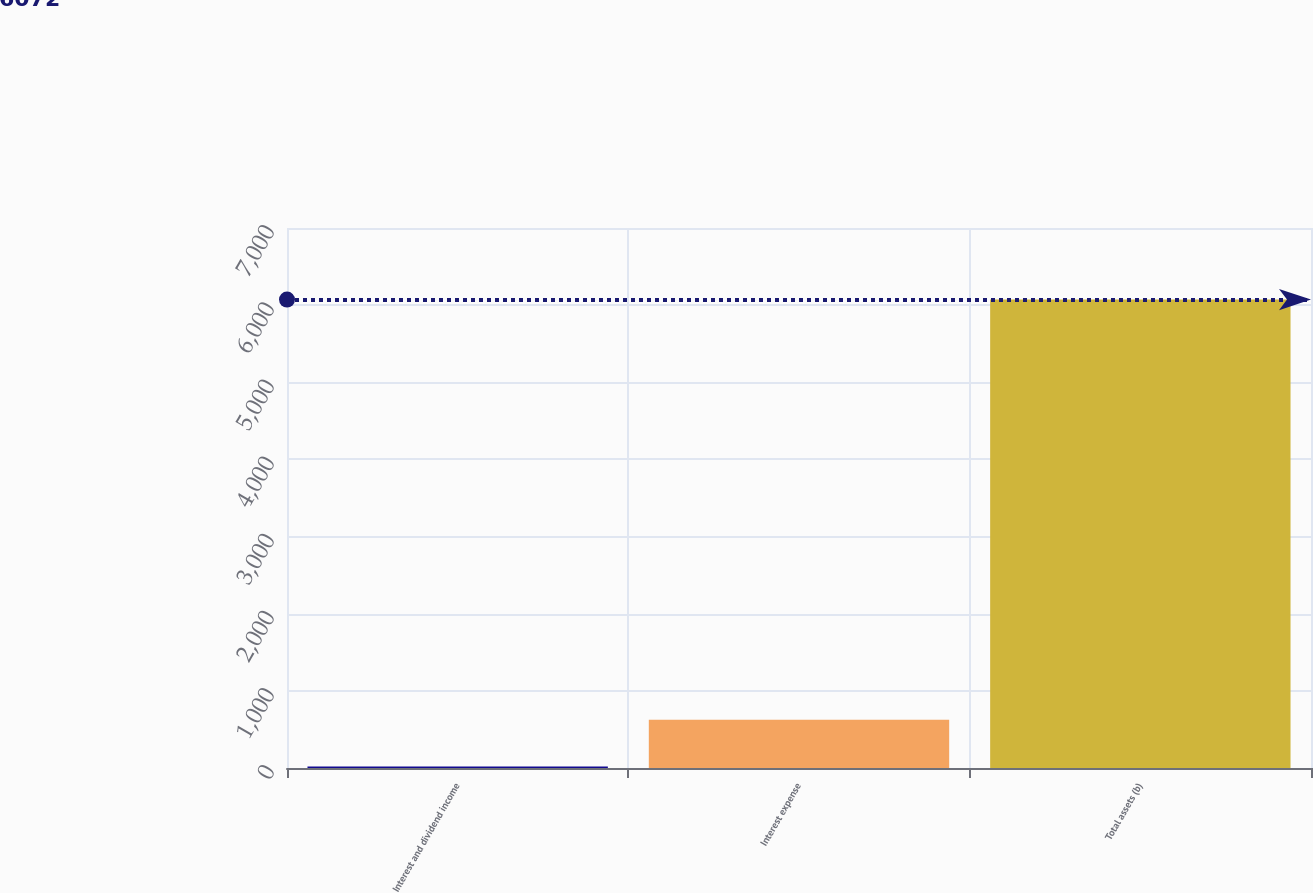Convert chart. <chart><loc_0><loc_0><loc_500><loc_500><bar_chart><fcel>Interest and dividend income<fcel>Interest expense<fcel>Total assets (b)<nl><fcel>21<fcel>626.1<fcel>6072<nl></chart> 